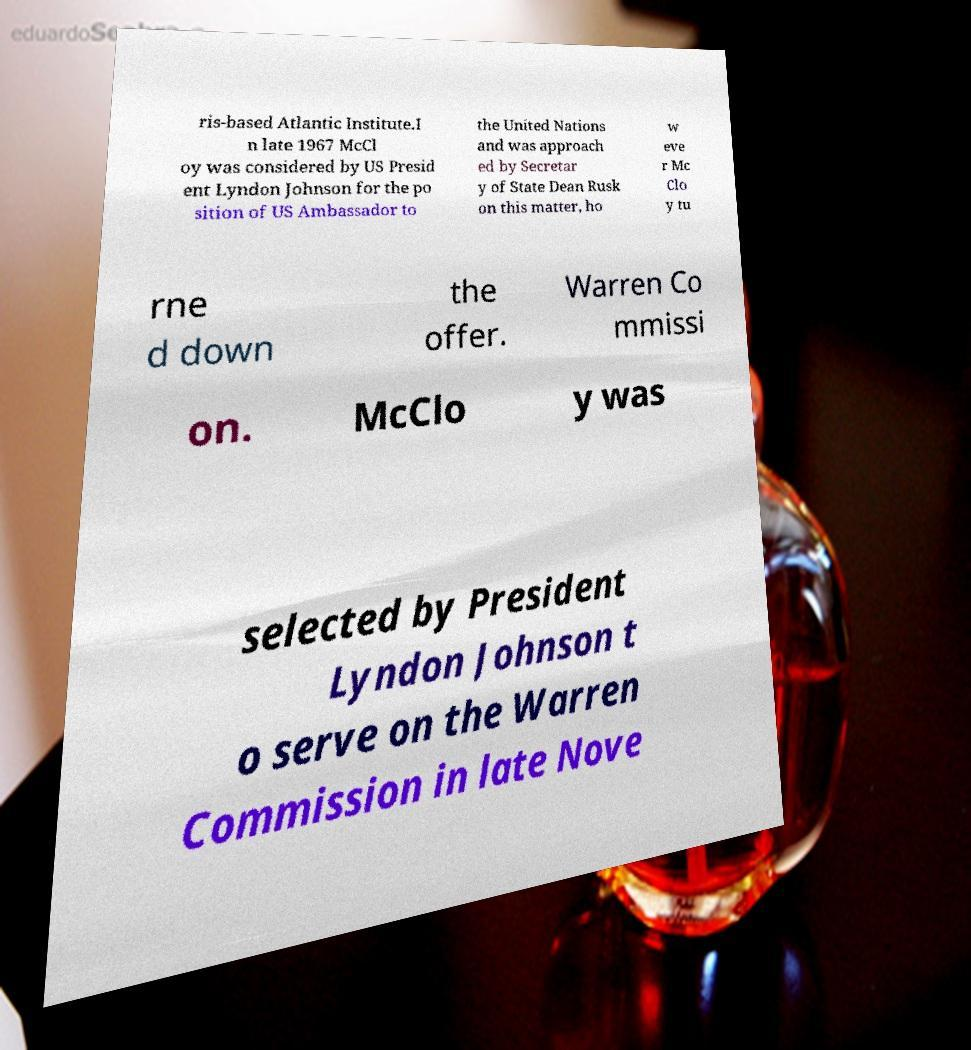Could you assist in decoding the text presented in this image and type it out clearly? ris-based Atlantic Institute.I n late 1967 McCl oy was considered by US Presid ent Lyndon Johnson for the po sition of US Ambassador to the United Nations and was approach ed by Secretar y of State Dean Rusk on this matter, ho w eve r Mc Clo y tu rne d down the offer. Warren Co mmissi on. McClo y was selected by President Lyndon Johnson t o serve on the Warren Commission in late Nove 